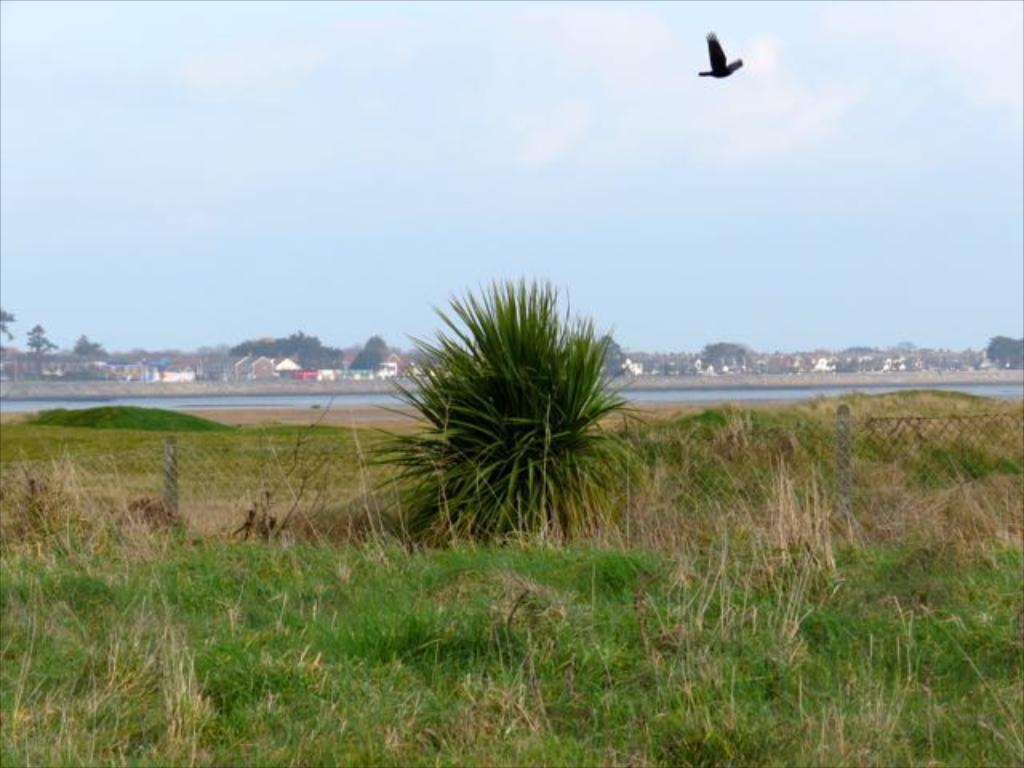What type of vegetation covers the land in the image? The land is covered with grass in the image. What can be seen in the distance? There are houses and trees in the distance. What is the mesh used for in the image? The purpose of the mesh in the image is not specified, but it is visible. What other types of vegetation are present in the image? There are plants in the image. Can you describe any animals in the image? A bird is flying in the air in the image. What type of quartz can be seen in the image? There is no quartz present in the image. How many lizards are visible in the image? There are no lizards visible in the image. 